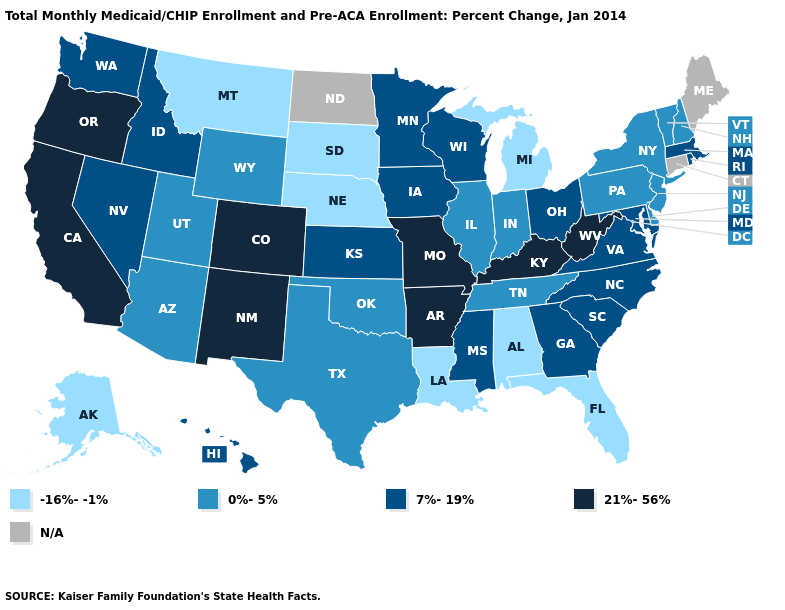Name the states that have a value in the range 21%-56%?
Write a very short answer. Arkansas, California, Colorado, Kentucky, Missouri, New Mexico, Oregon, West Virginia. Name the states that have a value in the range 7%-19%?
Short answer required. Georgia, Hawaii, Idaho, Iowa, Kansas, Maryland, Massachusetts, Minnesota, Mississippi, Nevada, North Carolina, Ohio, Rhode Island, South Carolina, Virginia, Washington, Wisconsin. What is the highest value in states that border Virginia?
Give a very brief answer. 21%-56%. What is the lowest value in the USA?
Be succinct. -16%--1%. What is the value of Texas?
Short answer required. 0%-5%. Among the states that border Maryland , does Delaware have the lowest value?
Be succinct. Yes. What is the lowest value in the USA?
Be succinct. -16%--1%. Name the states that have a value in the range -16%--1%?
Short answer required. Alabama, Alaska, Florida, Louisiana, Michigan, Montana, Nebraska, South Dakota. Which states have the lowest value in the USA?
Concise answer only. Alabama, Alaska, Florida, Louisiana, Michigan, Montana, Nebraska, South Dakota. What is the value of West Virginia?
Quick response, please. 21%-56%. What is the lowest value in states that border Illinois?
Short answer required. 0%-5%. Does Wisconsin have the highest value in the MidWest?
Write a very short answer. No. Name the states that have a value in the range -16%--1%?
Be succinct. Alabama, Alaska, Florida, Louisiana, Michigan, Montana, Nebraska, South Dakota. Name the states that have a value in the range 7%-19%?
Keep it brief. Georgia, Hawaii, Idaho, Iowa, Kansas, Maryland, Massachusetts, Minnesota, Mississippi, Nevada, North Carolina, Ohio, Rhode Island, South Carolina, Virginia, Washington, Wisconsin. Name the states that have a value in the range -16%--1%?
Keep it brief. Alabama, Alaska, Florida, Louisiana, Michigan, Montana, Nebraska, South Dakota. 